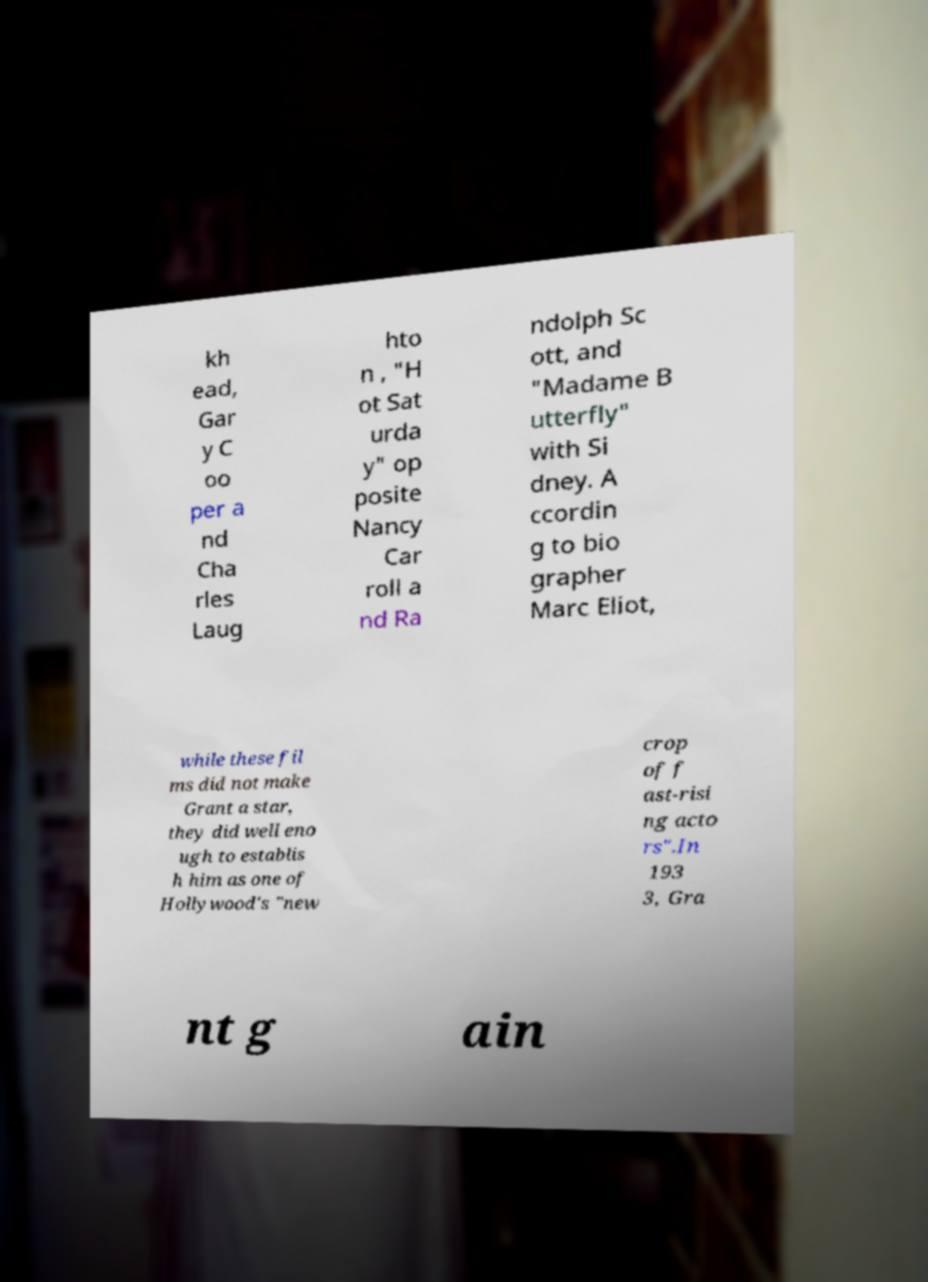Please read and relay the text visible in this image. What does it say? kh ead, Gar y C oo per a nd Cha rles Laug hto n , "H ot Sat urda y" op posite Nancy Car roll a nd Ra ndolph Sc ott, and "Madame B utterfly" with Si dney. A ccordin g to bio grapher Marc Eliot, while these fil ms did not make Grant a star, they did well eno ugh to establis h him as one of Hollywood's "new crop of f ast-risi ng acto rs".In 193 3, Gra nt g ain 